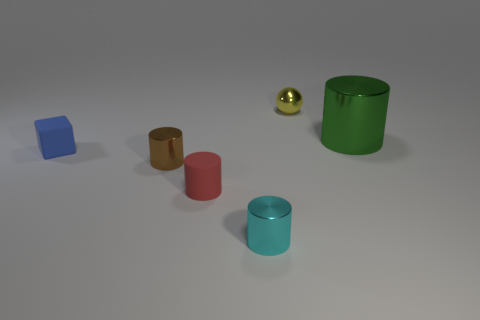Subtract all large green metal cylinders. How many cylinders are left? 3 Add 2 green cylinders. How many objects exist? 8 Subtract all brown cylinders. How many cylinders are left? 3 Subtract all balls. How many objects are left? 5 Subtract 1 spheres. How many spheres are left? 0 Subtract all green cylinders. Subtract all gray balls. How many cylinders are left? 3 Subtract all red cylinders. How many gray spheres are left? 0 Subtract all large objects. Subtract all red cylinders. How many objects are left? 4 Add 6 red matte things. How many red matte things are left? 7 Add 2 small blue metallic spheres. How many small blue metallic spheres exist? 2 